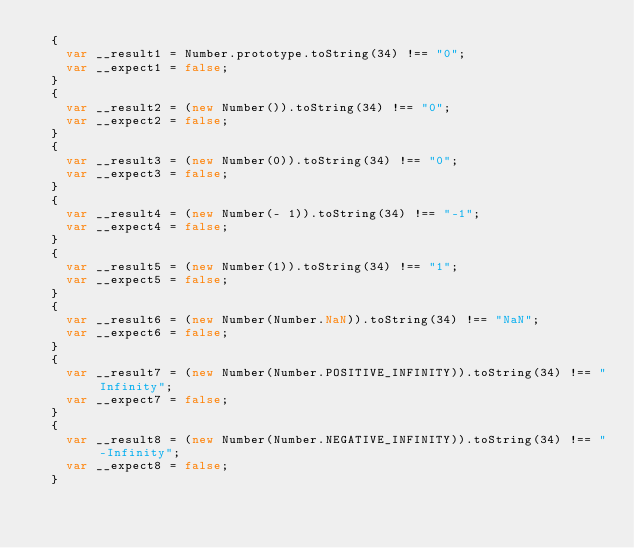Convert code to text. <code><loc_0><loc_0><loc_500><loc_500><_JavaScript_>  {
    var __result1 = Number.prototype.toString(34) !== "0";
    var __expect1 = false;
  }
  {
    var __result2 = (new Number()).toString(34) !== "0";
    var __expect2 = false;
  }
  {
    var __result3 = (new Number(0)).toString(34) !== "0";
    var __expect3 = false;
  }
  {
    var __result4 = (new Number(- 1)).toString(34) !== "-1";
    var __expect4 = false;
  }
  {
    var __result5 = (new Number(1)).toString(34) !== "1";
    var __expect5 = false;
  }
  {
    var __result6 = (new Number(Number.NaN)).toString(34) !== "NaN";
    var __expect6 = false;
  }
  {
    var __result7 = (new Number(Number.POSITIVE_INFINITY)).toString(34) !== "Infinity";
    var __expect7 = false;
  }
  {
    var __result8 = (new Number(Number.NEGATIVE_INFINITY)).toString(34) !== "-Infinity";
    var __expect8 = false;
  }
  </code> 